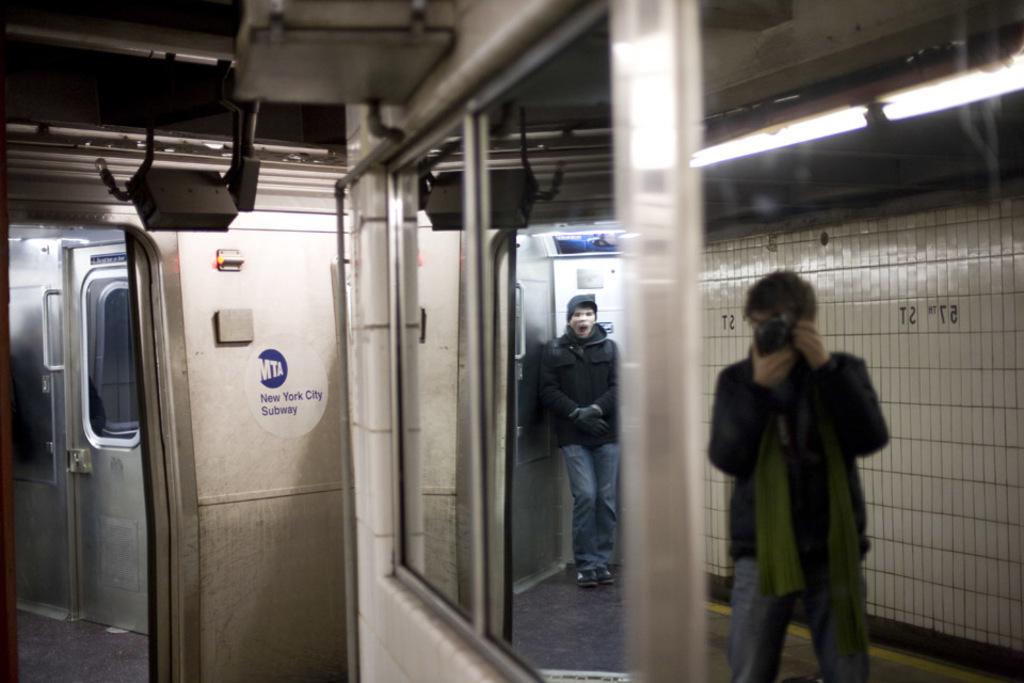What is written on the door?
Keep it short and to the point. New york city subway. What is written on the wall?
Keep it short and to the point. 57th st. 